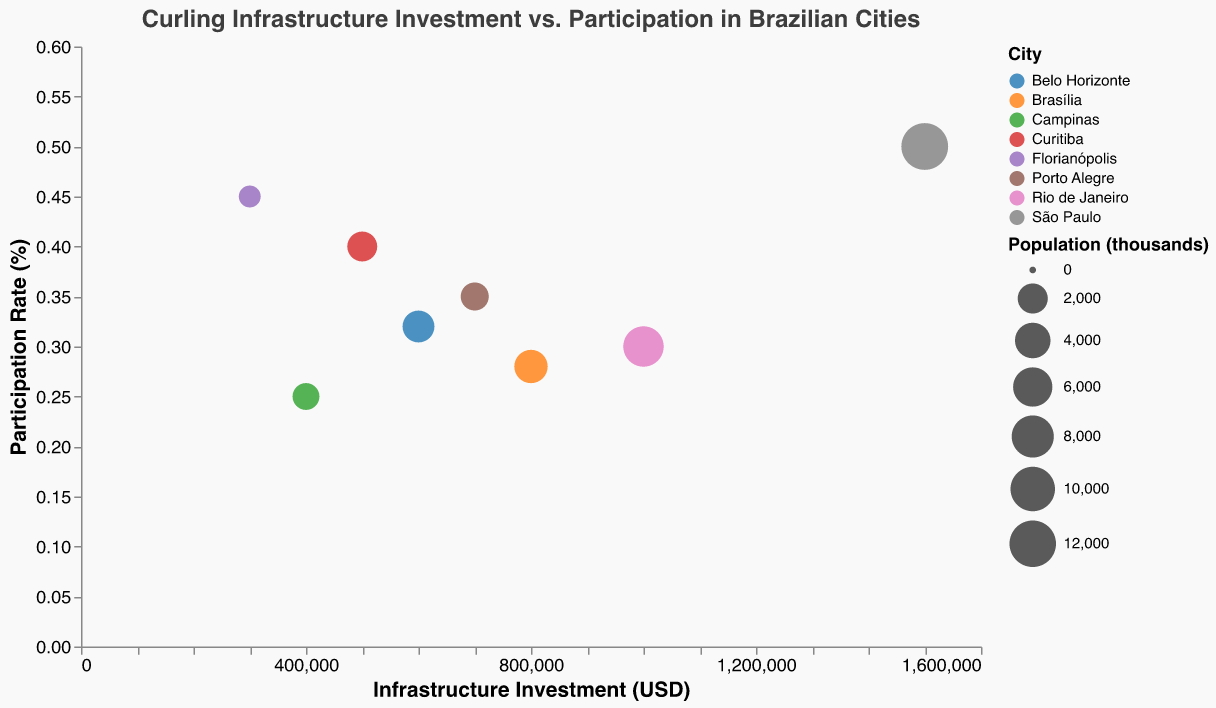What is the title of the plot? The title is displayed at the top of the plot. It is prominently placed and specifies the topic of the figure.
Answer: Curling Infrastructure Investment vs. Participation in Brazilian Cities How many cities are represented in the plot? The plot includes a distinct bubble for each city, which can be counted individually or identified by the legend.
Answer: 8 Which city has the highest participation rate in curling? Look for the bubble with the highest y-axis value, indicating the highest participation rate.
Answer: São Paulo Which city has the lowest investment in curling infrastructure? Identify the bubble closest to the origin on the x-axis, which represents the lowest investment.
Answer: Florianópolis How does the population size of São Paulo compare to other cities? Larger bubbles represent larger populations. São Paulo's bubble size is significantly larger than others, indicating it has a higher population.
Answer: São Paulo has the largest population What is the participation rate in Rio de Janeiro, and how does it compare to Brasília? Check the y-axis values for bubbles representing Rio de Janeiro and Brasília and compare their positions.
Answer: Rio de Janeiro: 0.3%; Brasília: 0.28%; Rio de Janeiro has a slightly higher participation rate Which city has the smallest population and what is its participation rate? Find the smallest bubble in size and read its associated y-axis value for participation.
Answer: Florianópolis; 0.45% Can we infer a trend between investment in infrastructure and participation rate? Observe the general direction of the data points. Most cities with higher investments have higher participation rates, but this is not universally true.
Answer: Investment generally correlates with participation rate What is the difference in investment between São Paulo and Campinas? Subtract the infrastructure investment of Campinas from that of São Paulo.
Answer: $1,100,000 Which city has the highest participation rate among those with over $500,000 in investment? Look at bubbles for cities with investments over $500,000 on the x-axis and identify which one has the highest y-axis value.
Answer: São Paulo 